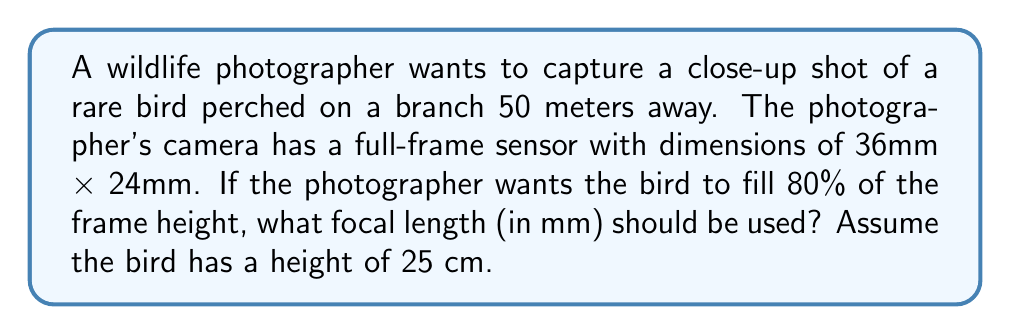Show me your answer to this math problem. To solve this problem, we'll use the principle of similar triangles and the formula for focal length:

$$\text{Focal Length} = \frac{\text{Image Size} \times \text{Subject Distance}}{\text{Subject Size}}$$

Let's break down the problem step-by-step:

1. Calculate the desired image size:
   - Frame height = 24mm
   - Bird should fill 80% of frame height
   - Desired image size = $24\text{mm} \times 0.80 = 19.2\text{mm}$

2. Convert all measurements to the same unit (mm):
   - Subject distance = 50m = 50,000mm
   - Subject size (bird height) = 25cm = 250mm

3. Apply the focal length formula:

   $$\text{Focal Length} = \frac{19.2\text{mm} \times 50,000\text{mm}}{250\text{mm}}$$

4. Simplify the calculation:

   $$\text{Focal Length} = \frac{960,000}{250} = 3,840\text{mm}$$

5. Convert to a more practical unit:

   $$\text{Focal Length} = 3,840\text{mm} \div 1,000 = 3.84\text{m} = 3,840\text{mm}$$

Therefore, the photographer needs a focal length of 3,840mm to capture the desired shot.
Answer: The required focal length is 3,840mm. 